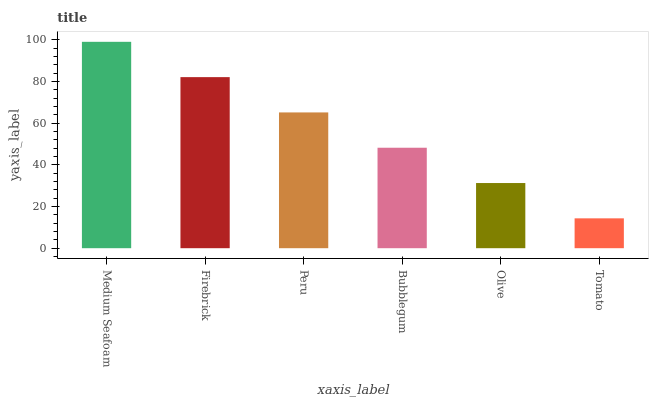Is Tomato the minimum?
Answer yes or no. Yes. Is Medium Seafoam the maximum?
Answer yes or no. Yes. Is Firebrick the minimum?
Answer yes or no. No. Is Firebrick the maximum?
Answer yes or no. No. Is Medium Seafoam greater than Firebrick?
Answer yes or no. Yes. Is Firebrick less than Medium Seafoam?
Answer yes or no. Yes. Is Firebrick greater than Medium Seafoam?
Answer yes or no. No. Is Medium Seafoam less than Firebrick?
Answer yes or no. No. Is Peru the high median?
Answer yes or no. Yes. Is Bubblegum the low median?
Answer yes or no. Yes. Is Olive the high median?
Answer yes or no. No. Is Medium Seafoam the low median?
Answer yes or no. No. 